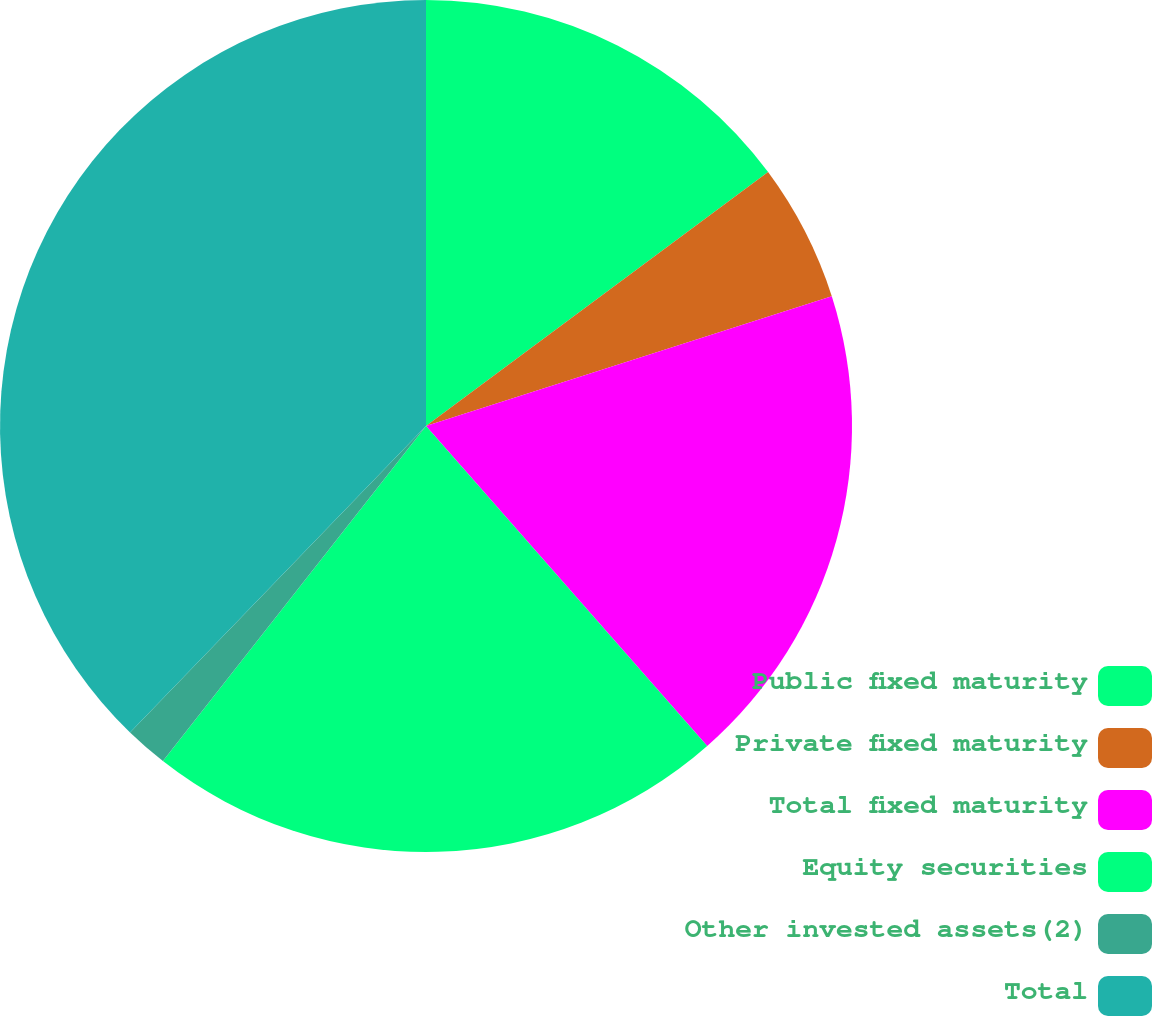<chart> <loc_0><loc_0><loc_500><loc_500><pie_chart><fcel>Public fixed maturity<fcel>Private fixed maturity<fcel>Total fixed maturity<fcel>Equity securities<fcel>Other invested assets(2)<fcel>Total<nl><fcel>14.84%<fcel>5.24%<fcel>18.45%<fcel>22.07%<fcel>1.63%<fcel>37.78%<nl></chart> 